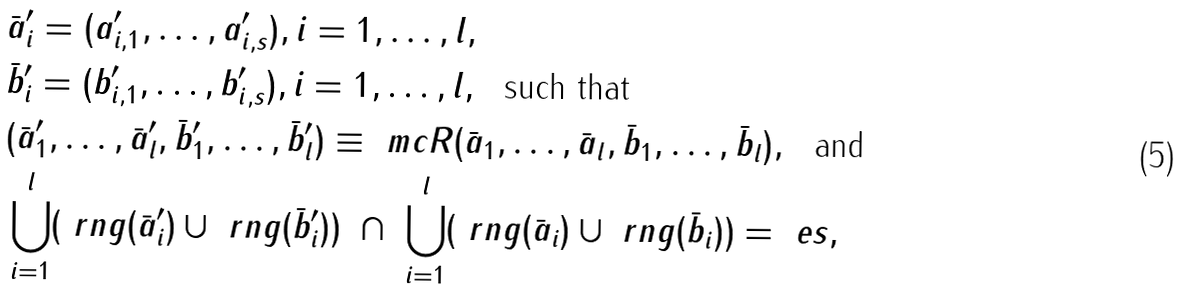Convert formula to latex. <formula><loc_0><loc_0><loc_500><loc_500>& \bar { a } ^ { \prime } _ { i } = ( a ^ { \prime } _ { i , 1 } , \dots , a ^ { \prime } _ { i , s } ) , i = 1 , \dots , l , \\ & \bar { b } ^ { \prime } _ { i } = ( b ^ { \prime } _ { i , 1 } , \dots , b ^ { \prime } _ { i , s } ) , i = 1 , \dots , l , \ \text { such that} \\ & ( \bar { a } ^ { \prime } _ { 1 } , \dots , \bar { a } ^ { \prime } _ { l } , \bar { b } ^ { \prime } _ { 1 } , \dots , \bar { b } ^ { \prime } _ { l } ) \equiv _ { \ } m c R ( \bar { a } _ { 1 } , \dots , \bar { a } _ { l } , \bar { b } _ { 1 } , \dots , \bar { b } _ { l } ) , \ \text { and} \\ & \bigcup _ { i = 1 } ^ { l } ( \ r n g ( \bar { a } ^ { \prime } _ { i } ) \cup \ r n g ( \bar { b } ^ { \prime } _ { i } ) ) \ \cap \ \bigcup _ { i = 1 } ^ { l } ( \ r n g ( \bar { a } _ { i } ) \cup \ r n g ( \bar { b } _ { i } ) ) = \ e s ,</formula> 